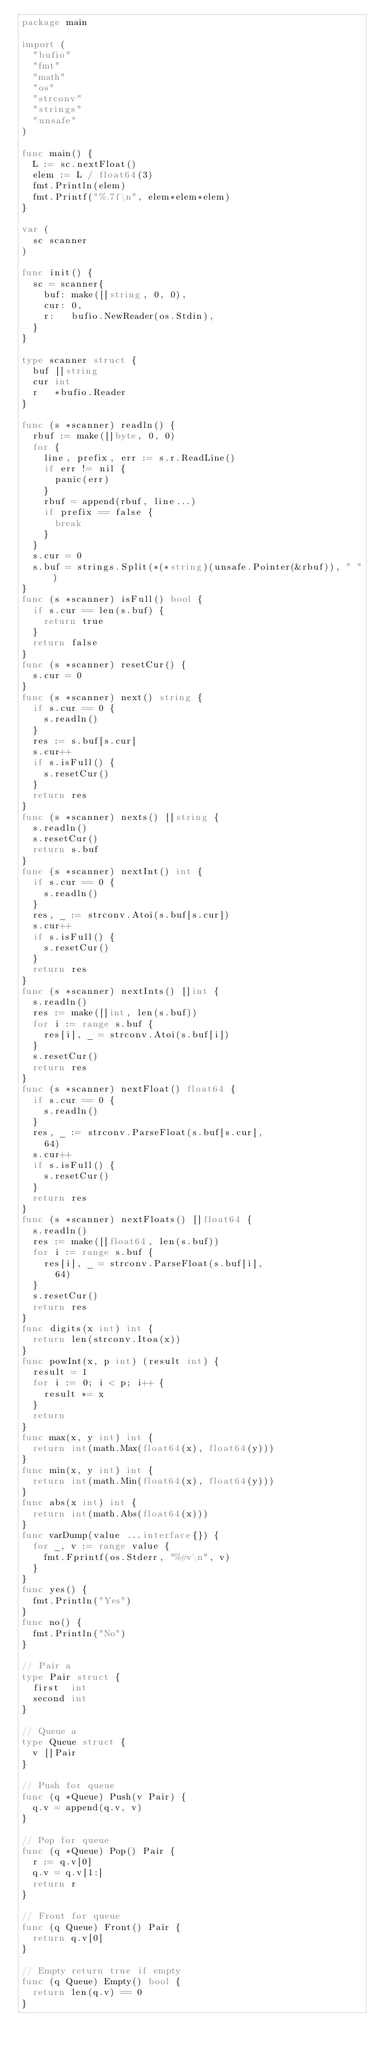<code> <loc_0><loc_0><loc_500><loc_500><_Go_>package main

import (
	"bufio"
	"fmt"
	"math"
	"os"
	"strconv"
	"strings"
	"unsafe"
)

func main() {
	L := sc.nextFloat()
	elem := L / float64(3)
	fmt.Println(elem)
	fmt.Printf("%.7f\n", elem*elem*elem)
}

var (
	sc scanner
)

func init() {
	sc = scanner{
		buf: make([]string, 0, 0),
		cur: 0,
		r:   bufio.NewReader(os.Stdin),
	}
}

type scanner struct {
	buf []string
	cur int
	r   *bufio.Reader
}

func (s *scanner) readln() {
	rbuf := make([]byte, 0, 0)
	for {
		line, prefix, err := s.r.ReadLine()
		if err != nil {
			panic(err)
		}
		rbuf = append(rbuf, line...)
		if prefix == false {
			break
		}
	}
	s.cur = 0
	s.buf = strings.Split(*(*string)(unsafe.Pointer(&rbuf)), " ")
}
func (s *scanner) isFull() bool {
	if s.cur == len(s.buf) {
		return true
	}
	return false
}
func (s *scanner) resetCur() {
	s.cur = 0
}
func (s *scanner) next() string {
	if s.cur == 0 {
		s.readln()
	}
	res := s.buf[s.cur]
	s.cur++
	if s.isFull() {
		s.resetCur()
	}
	return res
}
func (s *scanner) nexts() []string {
	s.readln()
	s.resetCur()
	return s.buf
}
func (s *scanner) nextInt() int {
	if s.cur == 0 {
		s.readln()
	}
	res, _ := strconv.Atoi(s.buf[s.cur])
	s.cur++
	if s.isFull() {
		s.resetCur()
	}
	return res
}
func (s *scanner) nextInts() []int {
	s.readln()
	res := make([]int, len(s.buf))
	for i := range s.buf {
		res[i], _ = strconv.Atoi(s.buf[i])
	}
	s.resetCur()
	return res
}
func (s *scanner) nextFloat() float64 {
	if s.cur == 0 {
		s.readln()
	}
	res, _ := strconv.ParseFloat(s.buf[s.cur],
		64)
	s.cur++
	if s.isFull() {
		s.resetCur()
	}
	return res
}
func (s *scanner) nextFloats() []float64 {
	s.readln()
	res := make([]float64, len(s.buf))
	for i := range s.buf {
		res[i], _ = strconv.ParseFloat(s.buf[i],
			64)
	}
	s.resetCur()
	return res
}
func digits(x int) int {
	return len(strconv.Itoa(x))
}
func powInt(x, p int) (result int) {
	result = 1
	for i := 0; i < p; i++ {
		result *= x
	}
	return
}
func max(x, y int) int {
	return int(math.Max(float64(x), float64(y)))
}
func min(x, y int) int {
	return int(math.Min(float64(x), float64(y)))
}
func abs(x int) int {
	return int(math.Abs(float64(x)))
}
func varDump(value ...interface{}) {
	for _, v := range value {
		fmt.Fprintf(os.Stderr, "%#v\n", v)
	}
}
func yes() {
	fmt.Println("Yes")
}
func no() {
	fmt.Println("No")
}

// Pair a
type Pair struct {
	first  int
	second int
}

// Queue a
type Queue struct {
	v []Pair
}

// Push for queue
func (q *Queue) Push(v Pair) {
	q.v = append(q.v, v)
}

// Pop for queue
func (q *Queue) Pop() Pair {
	r := q.v[0]
	q.v = q.v[1:]
	return r
}

// Front for queue
func (q Queue) Front() Pair {
	return q.v[0]
}

// Empty return true if empty
func (q Queue) Empty() bool {
	return len(q.v) == 0
}
</code> 